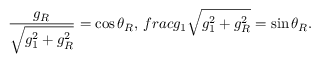Convert formula to latex. <formula><loc_0><loc_0><loc_500><loc_500>\frac { g _ { R } } { \sqrt { g _ { 1 } ^ { 2 } + g _ { R } ^ { 2 } } } = \cos \theta _ { R } , \, f r a c { g _ { 1 } } { \sqrt { g _ { 1 } ^ { 2 } + g _ { R } ^ { 2 } } } = \sin \theta _ { R } .</formula> 